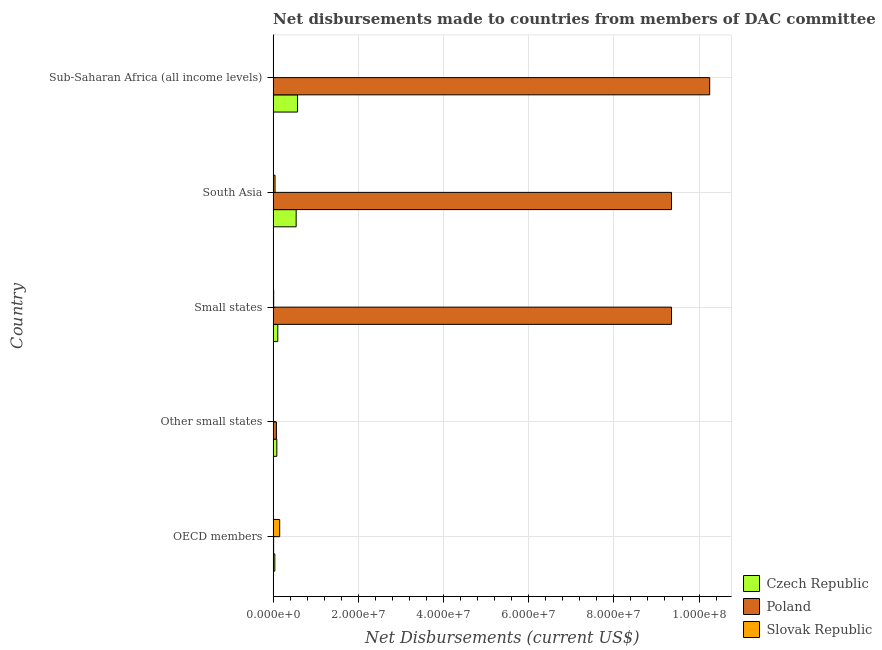How many groups of bars are there?
Give a very brief answer. 5. Are the number of bars per tick equal to the number of legend labels?
Your answer should be very brief. Yes. Are the number of bars on each tick of the Y-axis equal?
Your response must be concise. Yes. What is the label of the 5th group of bars from the top?
Offer a terse response. OECD members. In how many cases, is the number of bars for a given country not equal to the number of legend labels?
Provide a succinct answer. 0. What is the net disbursements made by poland in South Asia?
Ensure brevity in your answer.  9.35e+07. Across all countries, what is the maximum net disbursements made by slovak republic?
Provide a short and direct response. 1.54e+06. Across all countries, what is the minimum net disbursements made by poland?
Make the answer very short. 1.20e+05. In which country was the net disbursements made by slovak republic maximum?
Make the answer very short. OECD members. In which country was the net disbursements made by czech republic minimum?
Keep it short and to the point. OECD members. What is the total net disbursements made by slovak republic in the graph?
Ensure brevity in your answer.  2.21e+06. What is the difference between the net disbursements made by poland in South Asia and that in Sub-Saharan Africa (all income levels)?
Offer a very short reply. -8.96e+06. What is the difference between the net disbursements made by slovak republic in South Asia and the net disbursements made by poland in Other small states?
Your response must be concise. -3.20e+05. What is the average net disbursements made by czech republic per country?
Your response must be concise. 2.70e+06. What is the difference between the net disbursements made by czech republic and net disbursements made by slovak republic in Small states?
Ensure brevity in your answer.  9.60e+05. What is the ratio of the net disbursements made by slovak republic in OECD members to that in South Asia?
Provide a short and direct response. 3.42. Is the difference between the net disbursements made by slovak republic in Other small states and Small states greater than the difference between the net disbursements made by poland in Other small states and Small states?
Your answer should be very brief. Yes. What is the difference between the highest and the second highest net disbursements made by poland?
Offer a very short reply. 8.96e+06. What is the difference between the highest and the lowest net disbursements made by slovak republic?
Your response must be concise. 1.52e+06. In how many countries, is the net disbursements made by slovak republic greater than the average net disbursements made by slovak republic taken over all countries?
Offer a terse response. 2. What does the 1st bar from the top in Small states represents?
Keep it short and to the point. Slovak Republic. What does the 3rd bar from the bottom in Sub-Saharan Africa (all income levels) represents?
Give a very brief answer. Slovak Republic. Is it the case that in every country, the sum of the net disbursements made by czech republic and net disbursements made by poland is greater than the net disbursements made by slovak republic?
Your answer should be compact. No. Are all the bars in the graph horizontal?
Your answer should be compact. Yes. What is the difference between two consecutive major ticks on the X-axis?
Make the answer very short. 2.00e+07. Are the values on the major ticks of X-axis written in scientific E-notation?
Make the answer very short. Yes. Does the graph contain grids?
Keep it short and to the point. Yes. How many legend labels are there?
Ensure brevity in your answer.  3. What is the title of the graph?
Offer a terse response. Net disbursements made to countries from members of DAC committee. What is the label or title of the X-axis?
Make the answer very short. Net Disbursements (current US$). What is the Net Disbursements (current US$) in Czech Republic in OECD members?
Make the answer very short. 4.00e+05. What is the Net Disbursements (current US$) in Poland in OECD members?
Your response must be concise. 1.20e+05. What is the Net Disbursements (current US$) of Slovak Republic in OECD members?
Give a very brief answer. 1.54e+06. What is the Net Disbursements (current US$) of Czech Republic in Other small states?
Your response must be concise. 8.70e+05. What is the Net Disbursements (current US$) in Poland in Other small states?
Offer a very short reply. 7.70e+05. What is the Net Disbursements (current US$) of Slovak Republic in Other small states?
Provide a succinct answer. 7.00e+04. What is the Net Disbursements (current US$) in Czech Republic in Small states?
Ensure brevity in your answer.  1.09e+06. What is the Net Disbursements (current US$) in Poland in Small states?
Your answer should be compact. 9.35e+07. What is the Net Disbursements (current US$) of Slovak Republic in Small states?
Ensure brevity in your answer.  1.30e+05. What is the Net Disbursements (current US$) in Czech Republic in South Asia?
Ensure brevity in your answer.  5.41e+06. What is the Net Disbursements (current US$) of Poland in South Asia?
Your response must be concise. 9.35e+07. What is the Net Disbursements (current US$) of Czech Republic in Sub-Saharan Africa (all income levels)?
Keep it short and to the point. 5.74e+06. What is the Net Disbursements (current US$) of Poland in Sub-Saharan Africa (all income levels)?
Your response must be concise. 1.02e+08. What is the Net Disbursements (current US$) in Slovak Republic in Sub-Saharan Africa (all income levels)?
Provide a short and direct response. 2.00e+04. Across all countries, what is the maximum Net Disbursements (current US$) of Czech Republic?
Give a very brief answer. 5.74e+06. Across all countries, what is the maximum Net Disbursements (current US$) in Poland?
Give a very brief answer. 1.02e+08. Across all countries, what is the maximum Net Disbursements (current US$) in Slovak Republic?
Offer a terse response. 1.54e+06. Across all countries, what is the minimum Net Disbursements (current US$) in Czech Republic?
Provide a succinct answer. 4.00e+05. Across all countries, what is the minimum Net Disbursements (current US$) of Poland?
Give a very brief answer. 1.20e+05. What is the total Net Disbursements (current US$) in Czech Republic in the graph?
Provide a short and direct response. 1.35e+07. What is the total Net Disbursements (current US$) of Poland in the graph?
Your answer should be compact. 2.90e+08. What is the total Net Disbursements (current US$) in Slovak Republic in the graph?
Make the answer very short. 2.21e+06. What is the difference between the Net Disbursements (current US$) of Czech Republic in OECD members and that in Other small states?
Offer a very short reply. -4.70e+05. What is the difference between the Net Disbursements (current US$) of Poland in OECD members and that in Other small states?
Your response must be concise. -6.50e+05. What is the difference between the Net Disbursements (current US$) in Slovak Republic in OECD members and that in Other small states?
Your answer should be very brief. 1.47e+06. What is the difference between the Net Disbursements (current US$) of Czech Republic in OECD members and that in Small states?
Give a very brief answer. -6.90e+05. What is the difference between the Net Disbursements (current US$) in Poland in OECD members and that in Small states?
Offer a terse response. -9.34e+07. What is the difference between the Net Disbursements (current US$) in Slovak Republic in OECD members and that in Small states?
Ensure brevity in your answer.  1.41e+06. What is the difference between the Net Disbursements (current US$) in Czech Republic in OECD members and that in South Asia?
Your answer should be compact. -5.01e+06. What is the difference between the Net Disbursements (current US$) of Poland in OECD members and that in South Asia?
Ensure brevity in your answer.  -9.34e+07. What is the difference between the Net Disbursements (current US$) in Slovak Republic in OECD members and that in South Asia?
Keep it short and to the point. 1.09e+06. What is the difference between the Net Disbursements (current US$) in Czech Republic in OECD members and that in Sub-Saharan Africa (all income levels)?
Give a very brief answer. -5.34e+06. What is the difference between the Net Disbursements (current US$) of Poland in OECD members and that in Sub-Saharan Africa (all income levels)?
Ensure brevity in your answer.  -1.02e+08. What is the difference between the Net Disbursements (current US$) of Slovak Republic in OECD members and that in Sub-Saharan Africa (all income levels)?
Provide a succinct answer. 1.52e+06. What is the difference between the Net Disbursements (current US$) in Poland in Other small states and that in Small states?
Give a very brief answer. -9.28e+07. What is the difference between the Net Disbursements (current US$) of Czech Republic in Other small states and that in South Asia?
Provide a short and direct response. -4.54e+06. What is the difference between the Net Disbursements (current US$) of Poland in Other small states and that in South Asia?
Your response must be concise. -9.28e+07. What is the difference between the Net Disbursements (current US$) in Slovak Republic in Other small states and that in South Asia?
Offer a very short reply. -3.80e+05. What is the difference between the Net Disbursements (current US$) in Czech Republic in Other small states and that in Sub-Saharan Africa (all income levels)?
Provide a short and direct response. -4.87e+06. What is the difference between the Net Disbursements (current US$) in Poland in Other small states and that in Sub-Saharan Africa (all income levels)?
Offer a terse response. -1.02e+08. What is the difference between the Net Disbursements (current US$) of Slovak Republic in Other small states and that in Sub-Saharan Africa (all income levels)?
Your response must be concise. 5.00e+04. What is the difference between the Net Disbursements (current US$) of Czech Republic in Small states and that in South Asia?
Give a very brief answer. -4.32e+06. What is the difference between the Net Disbursements (current US$) of Poland in Small states and that in South Asia?
Provide a succinct answer. 0. What is the difference between the Net Disbursements (current US$) in Slovak Republic in Small states and that in South Asia?
Offer a terse response. -3.20e+05. What is the difference between the Net Disbursements (current US$) of Czech Republic in Small states and that in Sub-Saharan Africa (all income levels)?
Your answer should be very brief. -4.65e+06. What is the difference between the Net Disbursements (current US$) of Poland in Small states and that in Sub-Saharan Africa (all income levels)?
Give a very brief answer. -8.96e+06. What is the difference between the Net Disbursements (current US$) in Slovak Republic in Small states and that in Sub-Saharan Africa (all income levels)?
Your answer should be compact. 1.10e+05. What is the difference between the Net Disbursements (current US$) in Czech Republic in South Asia and that in Sub-Saharan Africa (all income levels)?
Your answer should be very brief. -3.30e+05. What is the difference between the Net Disbursements (current US$) of Poland in South Asia and that in Sub-Saharan Africa (all income levels)?
Give a very brief answer. -8.96e+06. What is the difference between the Net Disbursements (current US$) in Czech Republic in OECD members and the Net Disbursements (current US$) in Poland in Other small states?
Your response must be concise. -3.70e+05. What is the difference between the Net Disbursements (current US$) in Czech Republic in OECD members and the Net Disbursements (current US$) in Slovak Republic in Other small states?
Offer a very short reply. 3.30e+05. What is the difference between the Net Disbursements (current US$) of Czech Republic in OECD members and the Net Disbursements (current US$) of Poland in Small states?
Keep it short and to the point. -9.31e+07. What is the difference between the Net Disbursements (current US$) of Poland in OECD members and the Net Disbursements (current US$) of Slovak Republic in Small states?
Offer a terse response. -10000. What is the difference between the Net Disbursements (current US$) of Czech Republic in OECD members and the Net Disbursements (current US$) of Poland in South Asia?
Your answer should be compact. -9.31e+07. What is the difference between the Net Disbursements (current US$) of Czech Republic in OECD members and the Net Disbursements (current US$) of Slovak Republic in South Asia?
Your answer should be very brief. -5.00e+04. What is the difference between the Net Disbursements (current US$) of Poland in OECD members and the Net Disbursements (current US$) of Slovak Republic in South Asia?
Give a very brief answer. -3.30e+05. What is the difference between the Net Disbursements (current US$) in Czech Republic in OECD members and the Net Disbursements (current US$) in Poland in Sub-Saharan Africa (all income levels)?
Offer a very short reply. -1.02e+08. What is the difference between the Net Disbursements (current US$) of Czech Republic in OECD members and the Net Disbursements (current US$) of Slovak Republic in Sub-Saharan Africa (all income levels)?
Offer a very short reply. 3.80e+05. What is the difference between the Net Disbursements (current US$) of Poland in OECD members and the Net Disbursements (current US$) of Slovak Republic in Sub-Saharan Africa (all income levels)?
Provide a succinct answer. 1.00e+05. What is the difference between the Net Disbursements (current US$) of Czech Republic in Other small states and the Net Disbursements (current US$) of Poland in Small states?
Provide a succinct answer. -9.27e+07. What is the difference between the Net Disbursements (current US$) of Czech Republic in Other small states and the Net Disbursements (current US$) of Slovak Republic in Small states?
Make the answer very short. 7.40e+05. What is the difference between the Net Disbursements (current US$) of Poland in Other small states and the Net Disbursements (current US$) of Slovak Republic in Small states?
Provide a short and direct response. 6.40e+05. What is the difference between the Net Disbursements (current US$) of Czech Republic in Other small states and the Net Disbursements (current US$) of Poland in South Asia?
Ensure brevity in your answer.  -9.27e+07. What is the difference between the Net Disbursements (current US$) of Czech Republic in Other small states and the Net Disbursements (current US$) of Poland in Sub-Saharan Africa (all income levels)?
Your answer should be very brief. -1.02e+08. What is the difference between the Net Disbursements (current US$) of Czech Republic in Other small states and the Net Disbursements (current US$) of Slovak Republic in Sub-Saharan Africa (all income levels)?
Provide a succinct answer. 8.50e+05. What is the difference between the Net Disbursements (current US$) in Poland in Other small states and the Net Disbursements (current US$) in Slovak Republic in Sub-Saharan Africa (all income levels)?
Your answer should be compact. 7.50e+05. What is the difference between the Net Disbursements (current US$) in Czech Republic in Small states and the Net Disbursements (current US$) in Poland in South Asia?
Keep it short and to the point. -9.24e+07. What is the difference between the Net Disbursements (current US$) in Czech Republic in Small states and the Net Disbursements (current US$) in Slovak Republic in South Asia?
Give a very brief answer. 6.40e+05. What is the difference between the Net Disbursements (current US$) in Poland in Small states and the Net Disbursements (current US$) in Slovak Republic in South Asia?
Provide a succinct answer. 9.31e+07. What is the difference between the Net Disbursements (current US$) in Czech Republic in Small states and the Net Disbursements (current US$) in Poland in Sub-Saharan Africa (all income levels)?
Your answer should be very brief. -1.01e+08. What is the difference between the Net Disbursements (current US$) of Czech Republic in Small states and the Net Disbursements (current US$) of Slovak Republic in Sub-Saharan Africa (all income levels)?
Offer a very short reply. 1.07e+06. What is the difference between the Net Disbursements (current US$) of Poland in Small states and the Net Disbursements (current US$) of Slovak Republic in Sub-Saharan Africa (all income levels)?
Keep it short and to the point. 9.35e+07. What is the difference between the Net Disbursements (current US$) in Czech Republic in South Asia and the Net Disbursements (current US$) in Poland in Sub-Saharan Africa (all income levels)?
Provide a short and direct response. -9.71e+07. What is the difference between the Net Disbursements (current US$) of Czech Republic in South Asia and the Net Disbursements (current US$) of Slovak Republic in Sub-Saharan Africa (all income levels)?
Offer a very short reply. 5.39e+06. What is the difference between the Net Disbursements (current US$) in Poland in South Asia and the Net Disbursements (current US$) in Slovak Republic in Sub-Saharan Africa (all income levels)?
Make the answer very short. 9.35e+07. What is the average Net Disbursements (current US$) in Czech Republic per country?
Keep it short and to the point. 2.70e+06. What is the average Net Disbursements (current US$) of Poland per country?
Offer a terse response. 5.81e+07. What is the average Net Disbursements (current US$) in Slovak Republic per country?
Your answer should be compact. 4.42e+05. What is the difference between the Net Disbursements (current US$) of Czech Republic and Net Disbursements (current US$) of Slovak Republic in OECD members?
Provide a short and direct response. -1.14e+06. What is the difference between the Net Disbursements (current US$) in Poland and Net Disbursements (current US$) in Slovak Republic in OECD members?
Your response must be concise. -1.42e+06. What is the difference between the Net Disbursements (current US$) in Czech Republic and Net Disbursements (current US$) in Slovak Republic in Other small states?
Your response must be concise. 8.00e+05. What is the difference between the Net Disbursements (current US$) of Poland and Net Disbursements (current US$) of Slovak Republic in Other small states?
Offer a terse response. 7.00e+05. What is the difference between the Net Disbursements (current US$) of Czech Republic and Net Disbursements (current US$) of Poland in Small states?
Your answer should be very brief. -9.24e+07. What is the difference between the Net Disbursements (current US$) in Czech Republic and Net Disbursements (current US$) in Slovak Republic in Small states?
Ensure brevity in your answer.  9.60e+05. What is the difference between the Net Disbursements (current US$) of Poland and Net Disbursements (current US$) of Slovak Republic in Small states?
Your response must be concise. 9.34e+07. What is the difference between the Net Disbursements (current US$) in Czech Republic and Net Disbursements (current US$) in Poland in South Asia?
Offer a terse response. -8.81e+07. What is the difference between the Net Disbursements (current US$) in Czech Republic and Net Disbursements (current US$) in Slovak Republic in South Asia?
Give a very brief answer. 4.96e+06. What is the difference between the Net Disbursements (current US$) of Poland and Net Disbursements (current US$) of Slovak Republic in South Asia?
Give a very brief answer. 9.31e+07. What is the difference between the Net Disbursements (current US$) of Czech Republic and Net Disbursements (current US$) of Poland in Sub-Saharan Africa (all income levels)?
Ensure brevity in your answer.  -9.68e+07. What is the difference between the Net Disbursements (current US$) of Czech Republic and Net Disbursements (current US$) of Slovak Republic in Sub-Saharan Africa (all income levels)?
Your answer should be compact. 5.72e+06. What is the difference between the Net Disbursements (current US$) of Poland and Net Disbursements (current US$) of Slovak Republic in Sub-Saharan Africa (all income levels)?
Offer a terse response. 1.02e+08. What is the ratio of the Net Disbursements (current US$) in Czech Republic in OECD members to that in Other small states?
Give a very brief answer. 0.46. What is the ratio of the Net Disbursements (current US$) in Poland in OECD members to that in Other small states?
Offer a terse response. 0.16. What is the ratio of the Net Disbursements (current US$) of Slovak Republic in OECD members to that in Other small states?
Your answer should be very brief. 22. What is the ratio of the Net Disbursements (current US$) in Czech Republic in OECD members to that in Small states?
Your response must be concise. 0.37. What is the ratio of the Net Disbursements (current US$) in Poland in OECD members to that in Small states?
Give a very brief answer. 0. What is the ratio of the Net Disbursements (current US$) in Slovak Republic in OECD members to that in Small states?
Provide a succinct answer. 11.85. What is the ratio of the Net Disbursements (current US$) of Czech Republic in OECD members to that in South Asia?
Your answer should be compact. 0.07. What is the ratio of the Net Disbursements (current US$) of Poland in OECD members to that in South Asia?
Your answer should be very brief. 0. What is the ratio of the Net Disbursements (current US$) in Slovak Republic in OECD members to that in South Asia?
Your answer should be very brief. 3.42. What is the ratio of the Net Disbursements (current US$) of Czech Republic in OECD members to that in Sub-Saharan Africa (all income levels)?
Your answer should be very brief. 0.07. What is the ratio of the Net Disbursements (current US$) in Poland in OECD members to that in Sub-Saharan Africa (all income levels)?
Your answer should be very brief. 0. What is the ratio of the Net Disbursements (current US$) in Slovak Republic in OECD members to that in Sub-Saharan Africa (all income levels)?
Your answer should be very brief. 77. What is the ratio of the Net Disbursements (current US$) of Czech Republic in Other small states to that in Small states?
Your answer should be very brief. 0.8. What is the ratio of the Net Disbursements (current US$) in Poland in Other small states to that in Small states?
Offer a terse response. 0.01. What is the ratio of the Net Disbursements (current US$) in Slovak Republic in Other small states to that in Small states?
Your response must be concise. 0.54. What is the ratio of the Net Disbursements (current US$) of Czech Republic in Other small states to that in South Asia?
Offer a very short reply. 0.16. What is the ratio of the Net Disbursements (current US$) of Poland in Other small states to that in South Asia?
Make the answer very short. 0.01. What is the ratio of the Net Disbursements (current US$) in Slovak Republic in Other small states to that in South Asia?
Your response must be concise. 0.16. What is the ratio of the Net Disbursements (current US$) of Czech Republic in Other small states to that in Sub-Saharan Africa (all income levels)?
Provide a succinct answer. 0.15. What is the ratio of the Net Disbursements (current US$) in Poland in Other small states to that in Sub-Saharan Africa (all income levels)?
Your answer should be very brief. 0.01. What is the ratio of the Net Disbursements (current US$) of Slovak Republic in Other small states to that in Sub-Saharan Africa (all income levels)?
Provide a short and direct response. 3.5. What is the ratio of the Net Disbursements (current US$) in Czech Republic in Small states to that in South Asia?
Ensure brevity in your answer.  0.2. What is the ratio of the Net Disbursements (current US$) in Poland in Small states to that in South Asia?
Ensure brevity in your answer.  1. What is the ratio of the Net Disbursements (current US$) of Slovak Republic in Small states to that in South Asia?
Make the answer very short. 0.29. What is the ratio of the Net Disbursements (current US$) in Czech Republic in Small states to that in Sub-Saharan Africa (all income levels)?
Offer a very short reply. 0.19. What is the ratio of the Net Disbursements (current US$) in Poland in Small states to that in Sub-Saharan Africa (all income levels)?
Offer a very short reply. 0.91. What is the ratio of the Net Disbursements (current US$) in Czech Republic in South Asia to that in Sub-Saharan Africa (all income levels)?
Make the answer very short. 0.94. What is the ratio of the Net Disbursements (current US$) in Poland in South Asia to that in Sub-Saharan Africa (all income levels)?
Ensure brevity in your answer.  0.91. What is the ratio of the Net Disbursements (current US$) in Slovak Republic in South Asia to that in Sub-Saharan Africa (all income levels)?
Ensure brevity in your answer.  22.5. What is the difference between the highest and the second highest Net Disbursements (current US$) in Poland?
Make the answer very short. 8.96e+06. What is the difference between the highest and the second highest Net Disbursements (current US$) in Slovak Republic?
Offer a terse response. 1.09e+06. What is the difference between the highest and the lowest Net Disbursements (current US$) of Czech Republic?
Provide a succinct answer. 5.34e+06. What is the difference between the highest and the lowest Net Disbursements (current US$) of Poland?
Offer a very short reply. 1.02e+08. What is the difference between the highest and the lowest Net Disbursements (current US$) in Slovak Republic?
Give a very brief answer. 1.52e+06. 